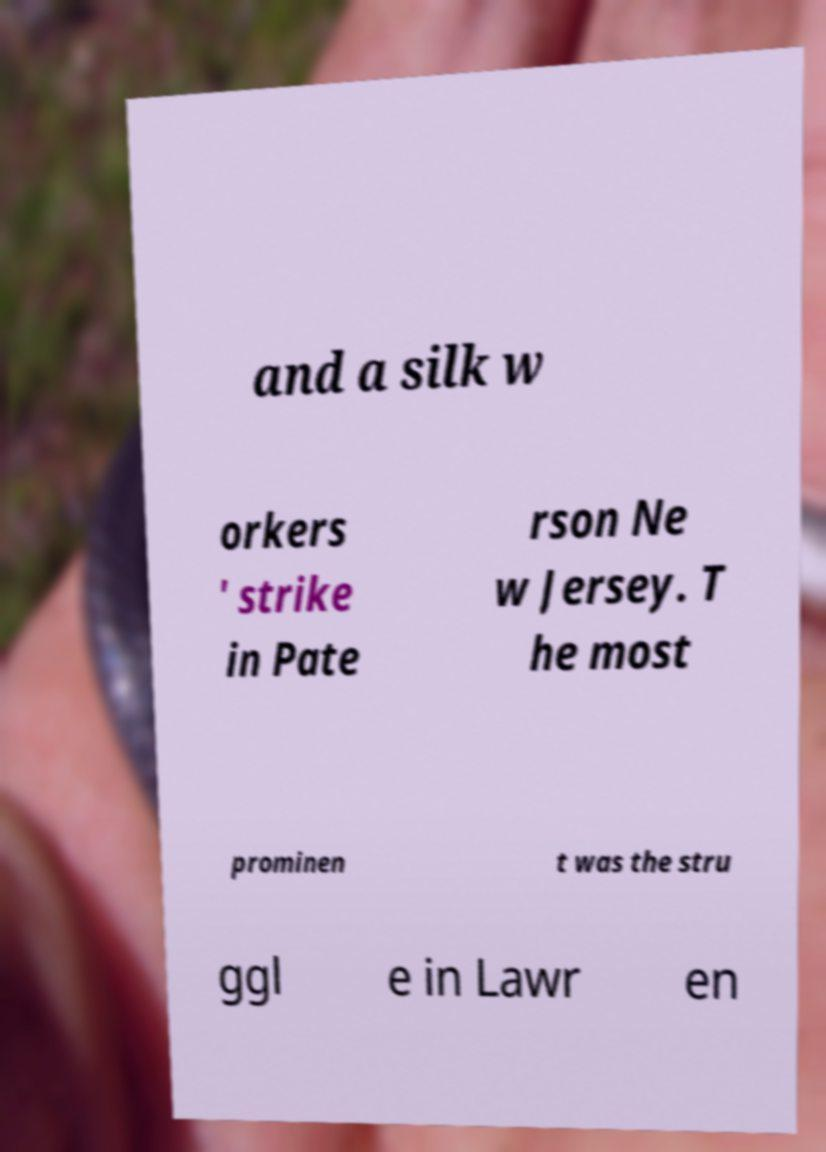Please identify and transcribe the text found in this image. and a silk w orkers ' strike in Pate rson Ne w Jersey. T he most prominen t was the stru ggl e in Lawr en 